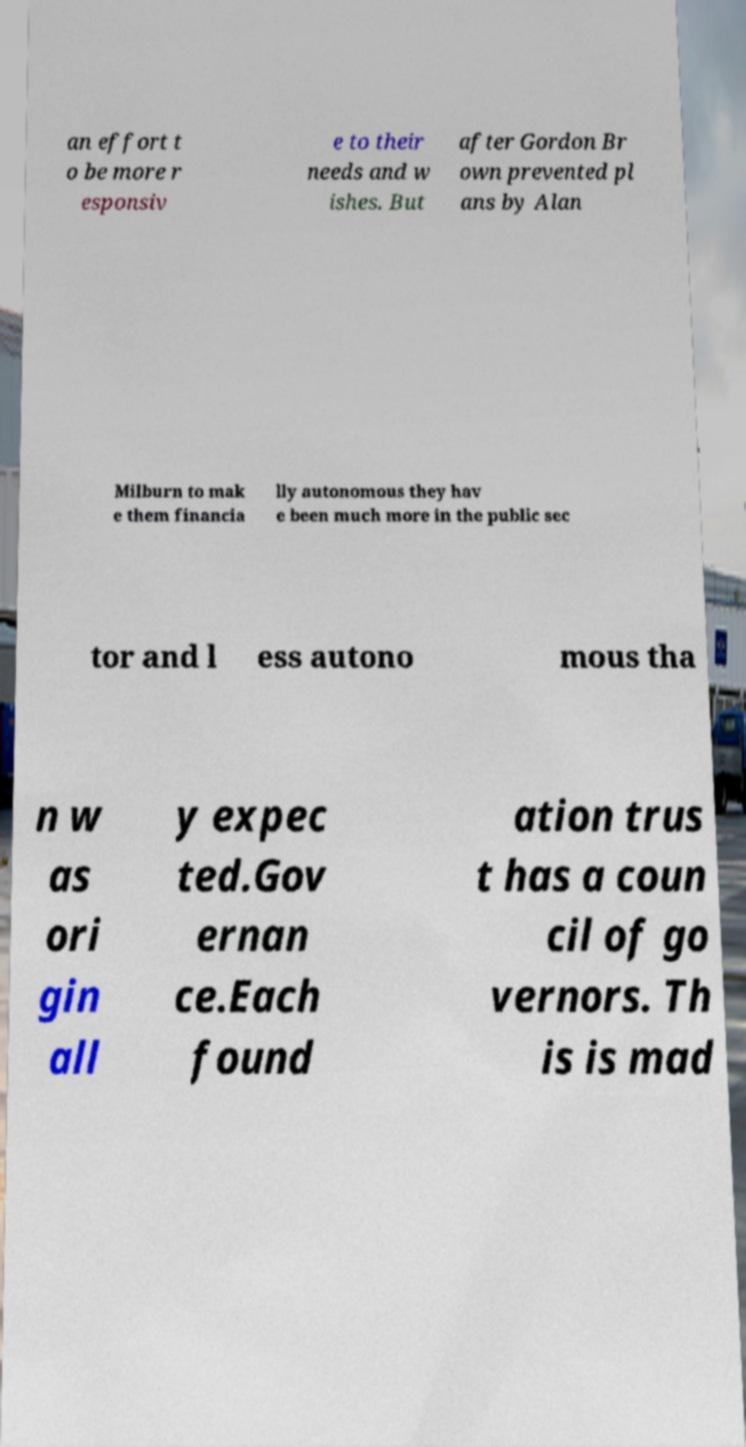What messages or text are displayed in this image? I need them in a readable, typed format. an effort t o be more r esponsiv e to their needs and w ishes. But after Gordon Br own prevented pl ans by Alan Milburn to mak e them financia lly autonomous they hav e been much more in the public sec tor and l ess autono mous tha n w as ori gin all y expec ted.Gov ernan ce.Each found ation trus t has a coun cil of go vernors. Th is is mad 